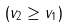Convert formula to latex. <formula><loc_0><loc_0><loc_500><loc_500>( v _ { 2 } \geq v _ { 1 } )</formula> 